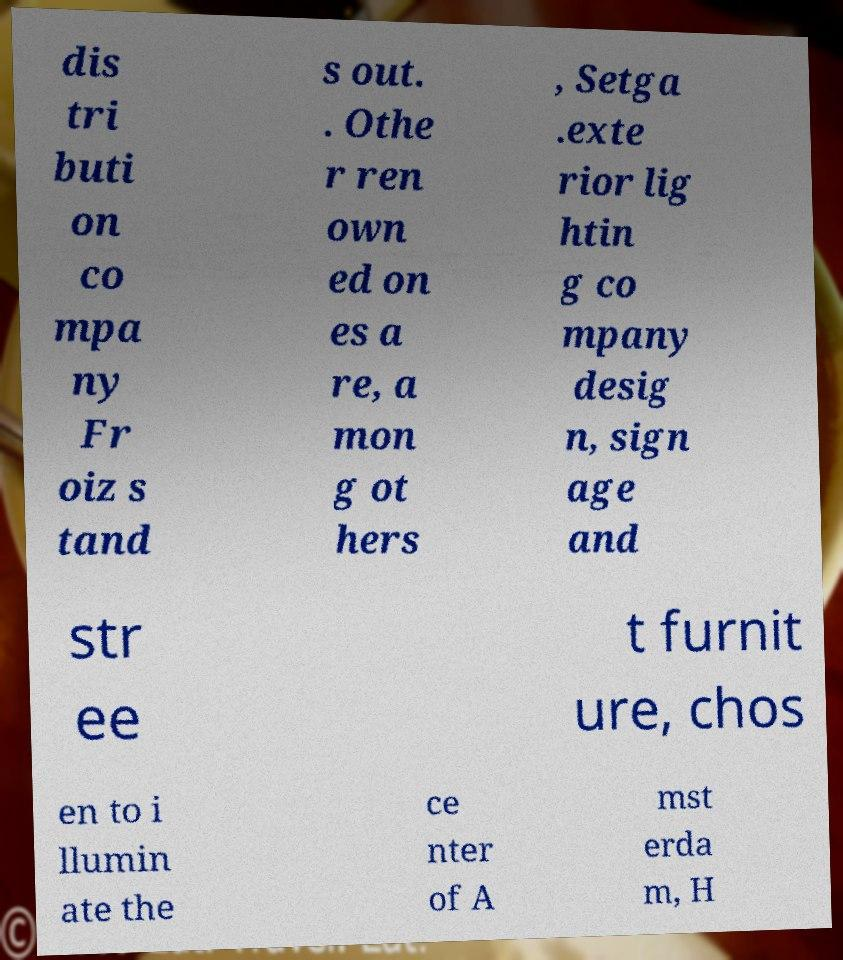Can you read and provide the text displayed in the image?This photo seems to have some interesting text. Can you extract and type it out for me? dis tri buti on co mpa ny Fr oiz s tand s out. . Othe r ren own ed on es a re, a mon g ot hers , Setga .exte rior lig htin g co mpany desig n, sign age and str ee t furnit ure, chos en to i llumin ate the ce nter of A mst erda m, H 